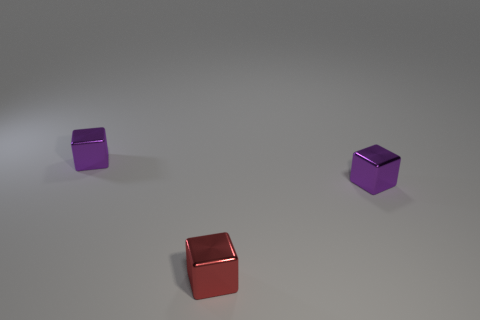How many shiny things are either tiny yellow spheres or tiny red cubes?
Offer a terse response. 1. There is a small red block that is left of the small purple metal object that is to the right of the red metallic thing; are there any purple blocks in front of it?
Ensure brevity in your answer.  No. Are there any tiny red objects behind the tiny red object?
Provide a short and direct response. No. There is a metallic thing that is on the right side of the small red thing; is there a tiny purple metal object that is behind it?
Provide a short and direct response. Yes. There is a object that is left of the red shiny thing; is its size the same as the purple cube that is to the right of the red thing?
Your response must be concise. Yes. How many large things are either red metallic things or matte cylinders?
Ensure brevity in your answer.  0. What is the purple cube behind the metal block that is right of the small red cube made of?
Give a very brief answer. Metal. Is there a small purple cube that has the same material as the red cube?
Your answer should be very brief. Yes. Is the red object made of the same material as the purple block that is to the right of the red shiny block?
Your answer should be very brief. Yes. How big is the red block that is in front of the tiny metal block that is on the left side of the tiny red shiny object?
Ensure brevity in your answer.  Small. 